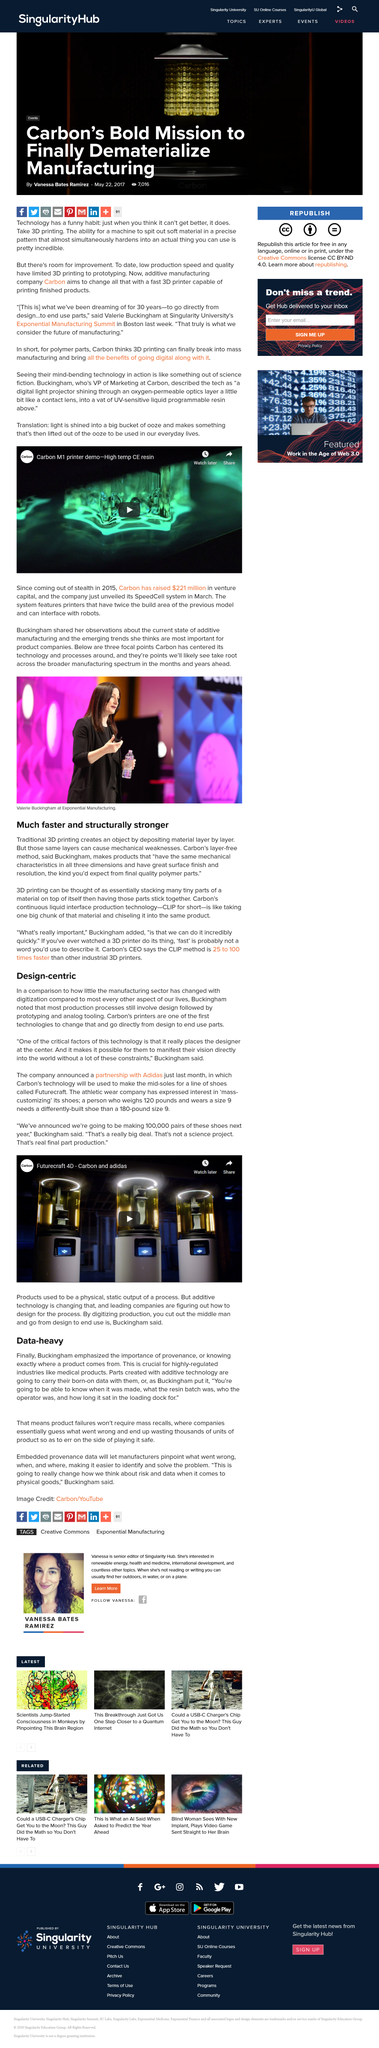Mention a couple of crucial points in this snapshot. The CLIP method offers several advantages over traditional 3D printing techniques, including significantly faster printing speeds and enhanced structural strength. These advantages make CLIP a promising solution for a wide range of applications in additive manufacturing. The process of production commonly involves the design phase, followed by the prototyping and analog tooling stages. Valerie Buckingham is the person pictured. We will be able to accurately determine the cause of a problem by leveraging embedded provenance data. Buckingham emphasized the importance of provenance. 